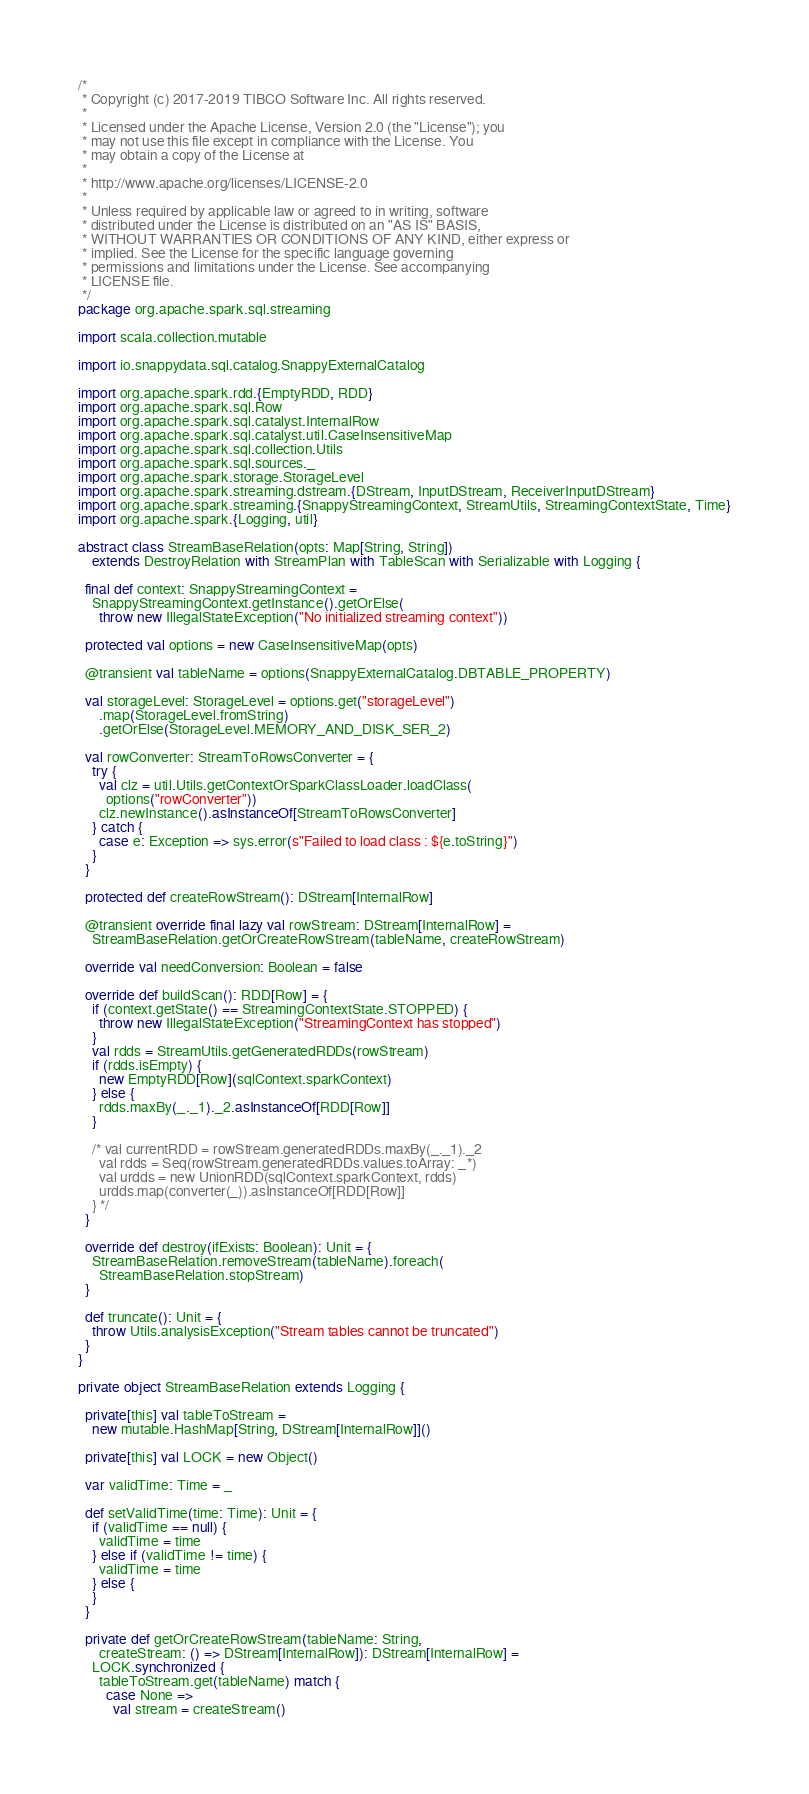Convert code to text. <code><loc_0><loc_0><loc_500><loc_500><_Scala_>/*
 * Copyright (c) 2017-2019 TIBCO Software Inc. All rights reserved.
 *
 * Licensed under the Apache License, Version 2.0 (the "License"); you
 * may not use this file except in compliance with the License. You
 * may obtain a copy of the License at
 *
 * http://www.apache.org/licenses/LICENSE-2.0
 *
 * Unless required by applicable law or agreed to in writing, software
 * distributed under the License is distributed on an "AS IS" BASIS,
 * WITHOUT WARRANTIES OR CONDITIONS OF ANY KIND, either express or
 * implied. See the License for the specific language governing
 * permissions and limitations under the License. See accompanying
 * LICENSE file.
 */
package org.apache.spark.sql.streaming

import scala.collection.mutable

import io.snappydata.sql.catalog.SnappyExternalCatalog

import org.apache.spark.rdd.{EmptyRDD, RDD}
import org.apache.spark.sql.Row
import org.apache.spark.sql.catalyst.InternalRow
import org.apache.spark.sql.catalyst.util.CaseInsensitiveMap
import org.apache.spark.sql.collection.Utils
import org.apache.spark.sql.sources._
import org.apache.spark.storage.StorageLevel
import org.apache.spark.streaming.dstream.{DStream, InputDStream, ReceiverInputDStream}
import org.apache.spark.streaming.{SnappyStreamingContext, StreamUtils, StreamingContextState, Time}
import org.apache.spark.{Logging, util}

abstract class StreamBaseRelation(opts: Map[String, String])
    extends DestroyRelation with StreamPlan with TableScan with Serializable with Logging {

  final def context: SnappyStreamingContext =
    SnappyStreamingContext.getInstance().getOrElse(
      throw new IllegalStateException("No initialized streaming context"))

  protected val options = new CaseInsensitiveMap(opts)

  @transient val tableName = options(SnappyExternalCatalog.DBTABLE_PROPERTY)

  val storageLevel: StorageLevel = options.get("storageLevel")
      .map(StorageLevel.fromString)
      .getOrElse(StorageLevel.MEMORY_AND_DISK_SER_2)

  val rowConverter: StreamToRowsConverter = {
    try {
      val clz = util.Utils.getContextOrSparkClassLoader.loadClass(
        options("rowConverter"))
      clz.newInstance().asInstanceOf[StreamToRowsConverter]
    } catch {
      case e: Exception => sys.error(s"Failed to load class : ${e.toString}")
    }
  }

  protected def createRowStream(): DStream[InternalRow]

  @transient override final lazy val rowStream: DStream[InternalRow] =
    StreamBaseRelation.getOrCreateRowStream(tableName, createRowStream)

  override val needConversion: Boolean = false

  override def buildScan(): RDD[Row] = {
    if (context.getState() == StreamingContextState.STOPPED) {
      throw new IllegalStateException("StreamingContext has stopped")
    }
    val rdds = StreamUtils.getGeneratedRDDs(rowStream)
    if (rdds.isEmpty) {
      new EmptyRDD[Row](sqlContext.sparkContext)
    } else {
      rdds.maxBy(_._1)._2.asInstanceOf[RDD[Row]]
    }

    /* val currentRDD = rowStream.generatedRDDs.maxBy(_._1)._2
      val rdds = Seq(rowStream.generatedRDDs.values.toArray: _*)
      val urdds = new UnionRDD(sqlContext.sparkContext, rdds)
      urdds.map(converter(_)).asInstanceOf[RDD[Row]]
    } */
  }

  override def destroy(ifExists: Boolean): Unit = {
    StreamBaseRelation.removeStream(tableName).foreach(
      StreamBaseRelation.stopStream)
  }

  def truncate(): Unit = {
    throw Utils.analysisException("Stream tables cannot be truncated")
  }
}

private object StreamBaseRelation extends Logging {

  private[this] val tableToStream =
    new mutable.HashMap[String, DStream[InternalRow]]()

  private[this] val LOCK = new Object()

  var validTime: Time = _

  def setValidTime(time: Time): Unit = {
    if (validTime == null) {
      validTime = time
    } else if (validTime != time) {
      validTime = time
    } else {
    }
  }

  private def getOrCreateRowStream(tableName: String,
      createStream: () => DStream[InternalRow]): DStream[InternalRow] =
    LOCK.synchronized {
      tableToStream.get(tableName) match {
        case None =>
          val stream = createStream()</code> 